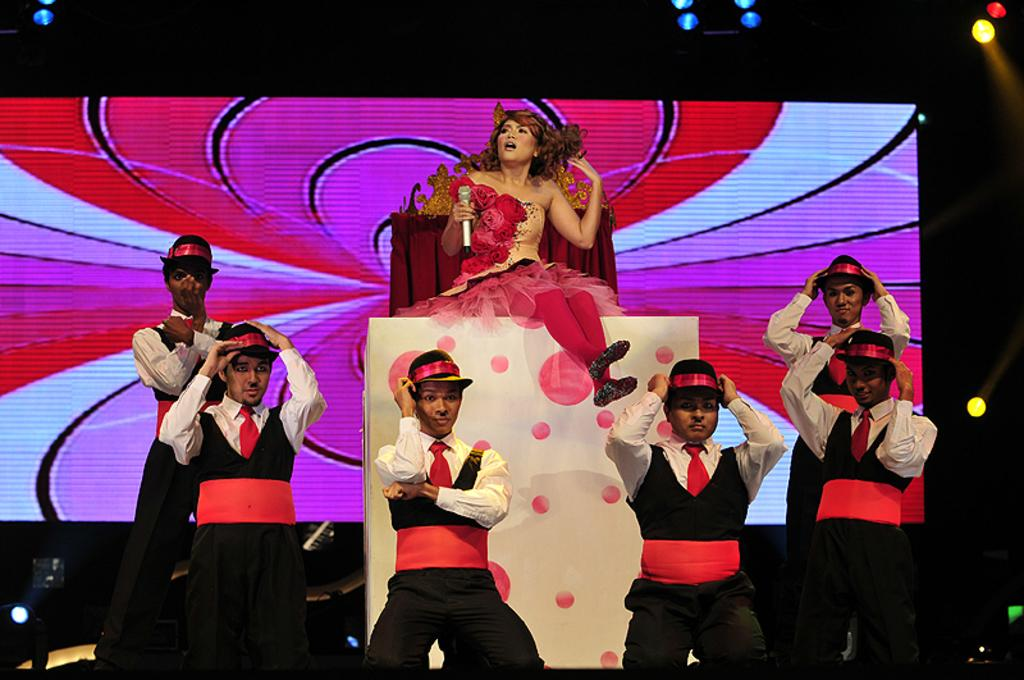How many people are in the image? There are people in the image, but the exact number is not specified. What is the lady holding in the image? The lady is holding a microphone in the image. What is the lady sitting on in the image? The lady is sitting on a white-colored object in the image. What can be seen in the background of the image? There is a screen and lights visible in the background of the image. What book is the lady reading to the dog in the image? There is no book or dog present in the image. How does the lady care for the dog in the image? There is no dog present in the image, so it is not possible to discuss how the lady cares for it. 